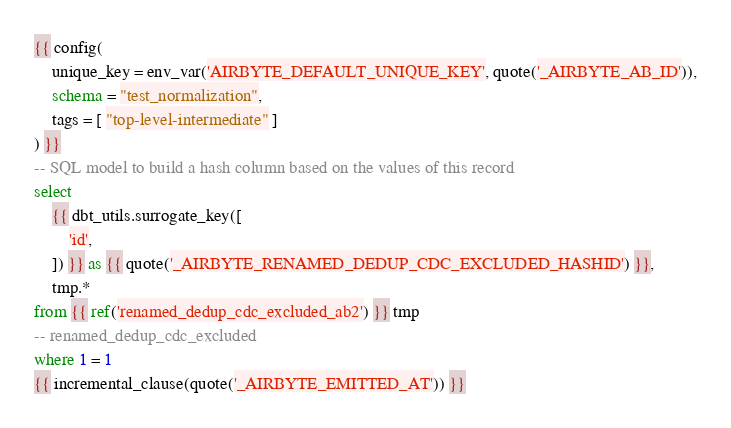Convert code to text. <code><loc_0><loc_0><loc_500><loc_500><_SQL_>{{ config(
    unique_key = env_var('AIRBYTE_DEFAULT_UNIQUE_KEY', quote('_AIRBYTE_AB_ID')),
    schema = "test_normalization",
    tags = [ "top-level-intermediate" ]
) }}
-- SQL model to build a hash column based on the values of this record
select
    {{ dbt_utils.surrogate_key([
        'id',
    ]) }} as {{ quote('_AIRBYTE_RENAMED_DEDUP_CDC_EXCLUDED_HASHID') }},
    tmp.*
from {{ ref('renamed_dedup_cdc_excluded_ab2') }} tmp
-- renamed_dedup_cdc_excluded
where 1 = 1
{{ incremental_clause(quote('_AIRBYTE_EMITTED_AT')) }}

</code> 